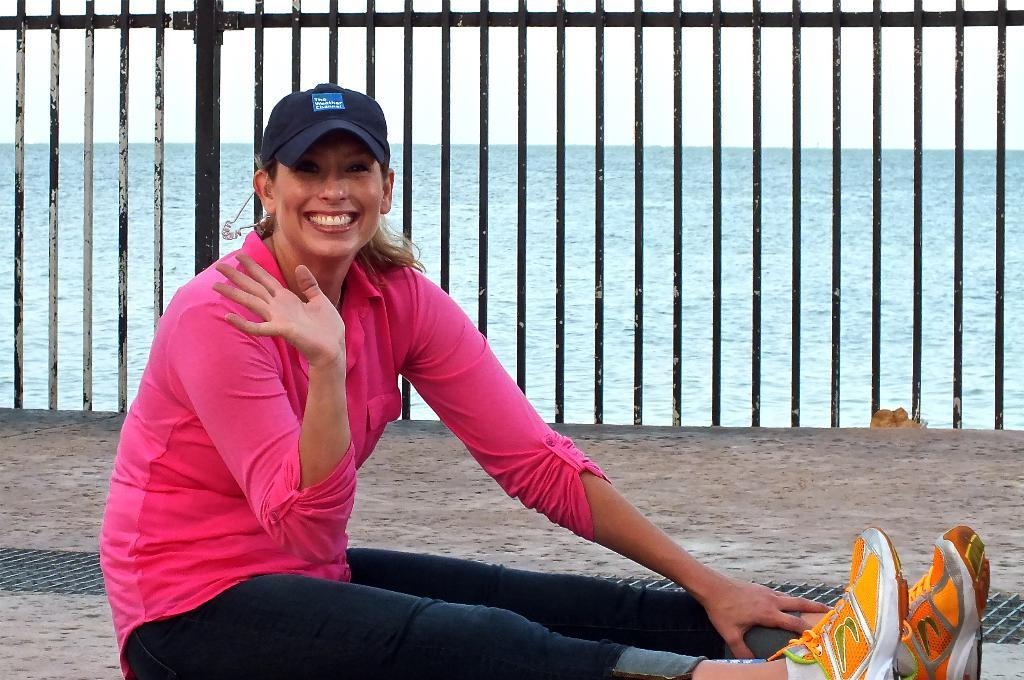Who is present in the image? There is a woman in the image. What is the woman doing in the image? The woman is sitting. What is the woman's facial expression in the image? The woman is smiling. What type of material can be seen in the image? There are metal rods visible in the image. What natural element is present in the image? There is water visible in the image. What type of yarn is being used to support the woman in the image? There is no yarn present in the image, and the woman is not being supported by any yarn. 